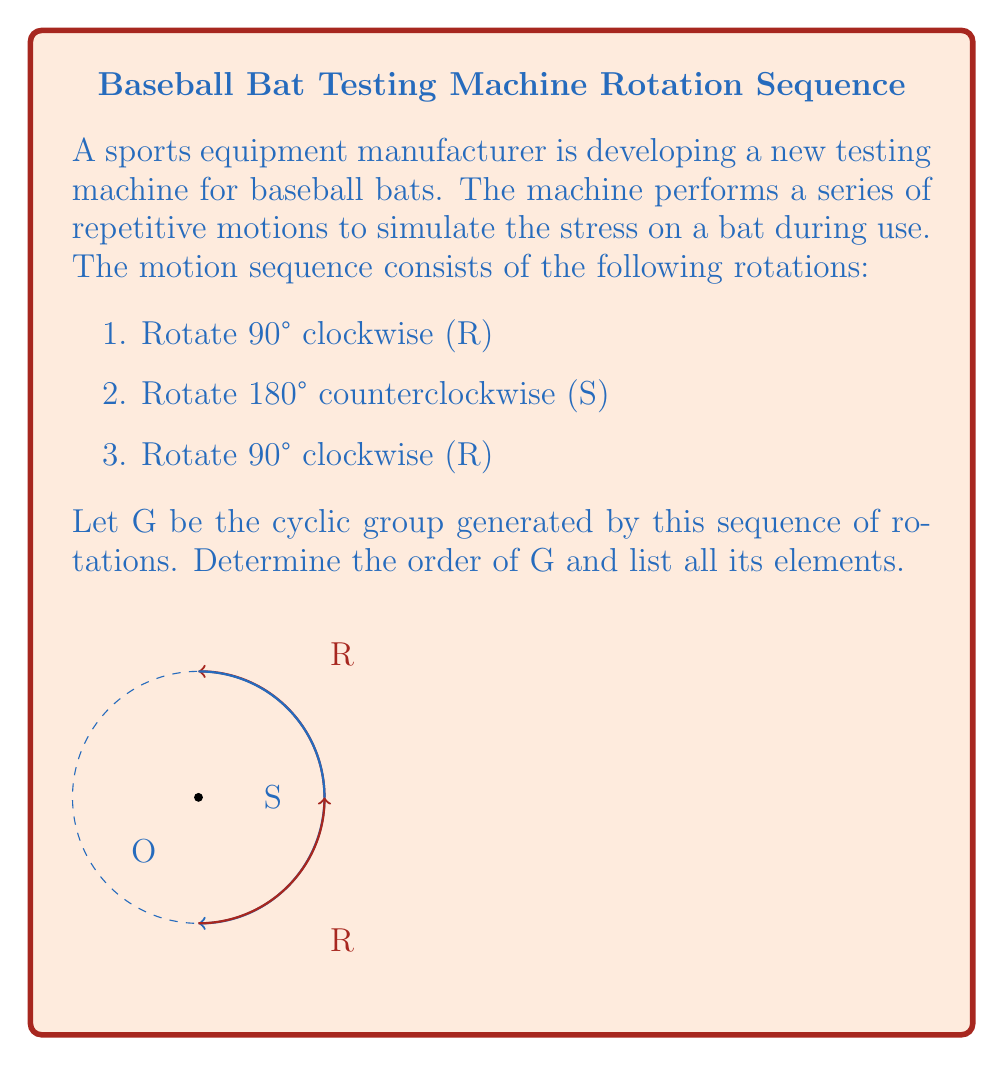What is the answer to this math problem? Let's approach this step-by-step:

1) First, we need to determine the net rotation of the sequence RSR:
   $R: 90°$ clockwise
   $S: 180°$ counterclockwise = $-180°$
   $R: 90°$ clockwise
   
   Net rotation = $90° + (-180°) + 90° = 0°$

2) This means that the sequence RSR is equivalent to the identity element, which we'll call e.

3) To find the elements of the group, let's see what happens when we apply the sequence multiple times:
   
   $(RSR)^1 = e$
   $(RSR)^2 = e$
   $(RSR)^3 = e$
   and so on...

4) No matter how many times we apply RSR, we always get back to the identity element.

5) Therefore, the group G consists of only one element: the identity element e.

6) The order of a group is the number of elements in the group. In this case, |G| = 1.

Thus, G is the trivial group, containing only the identity element.
Answer: $|G| = 1$, $G = \{e\}$ 